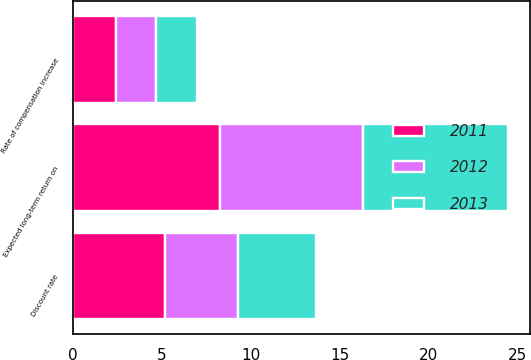<chart> <loc_0><loc_0><loc_500><loc_500><stacked_bar_chart><ecel><fcel>Discount rate<fcel>Expected long-term return on<fcel>Rate of compensation increase<nl><fcel>2012<fcel>4.1<fcel>8<fcel>2.3<nl><fcel>2013<fcel>4.4<fcel>8.2<fcel>2.3<nl><fcel>2011<fcel>5.2<fcel>8.3<fcel>2.4<nl></chart> 